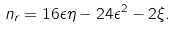<formula> <loc_0><loc_0><loc_500><loc_500>n _ { r } = 1 6 \epsilon \eta - 2 4 \epsilon ^ { 2 } - 2 \xi .</formula> 